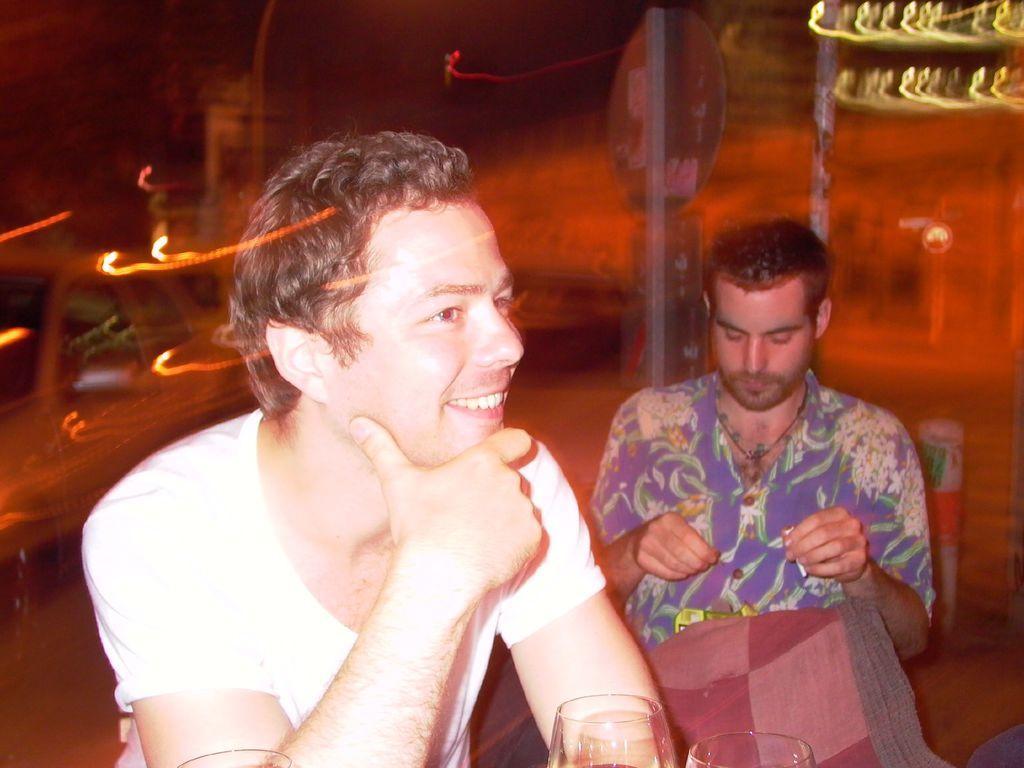How would you summarize this image in a sentence or two? In this picture there is a boy wearing a white color t-shirt is smiling and looking to the right side. Behind there is a another boy wearing blue color full shirt and looking to the hands. Behind there is a blur background of the road. 